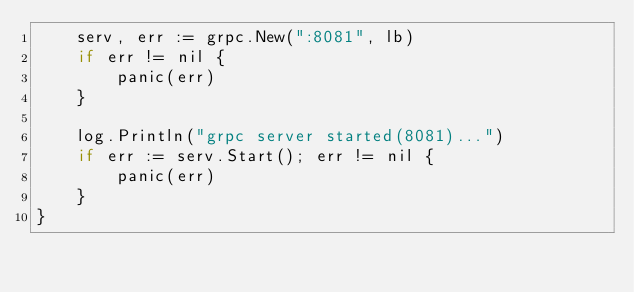<code> <loc_0><loc_0><loc_500><loc_500><_Go_>	serv, err := grpc.New(":8081", lb)
	if err != nil {
		panic(err)
	}

	log.Println("grpc server started(8081)...")
	if err := serv.Start(); err != nil {
		panic(err)
	}
}
</code> 